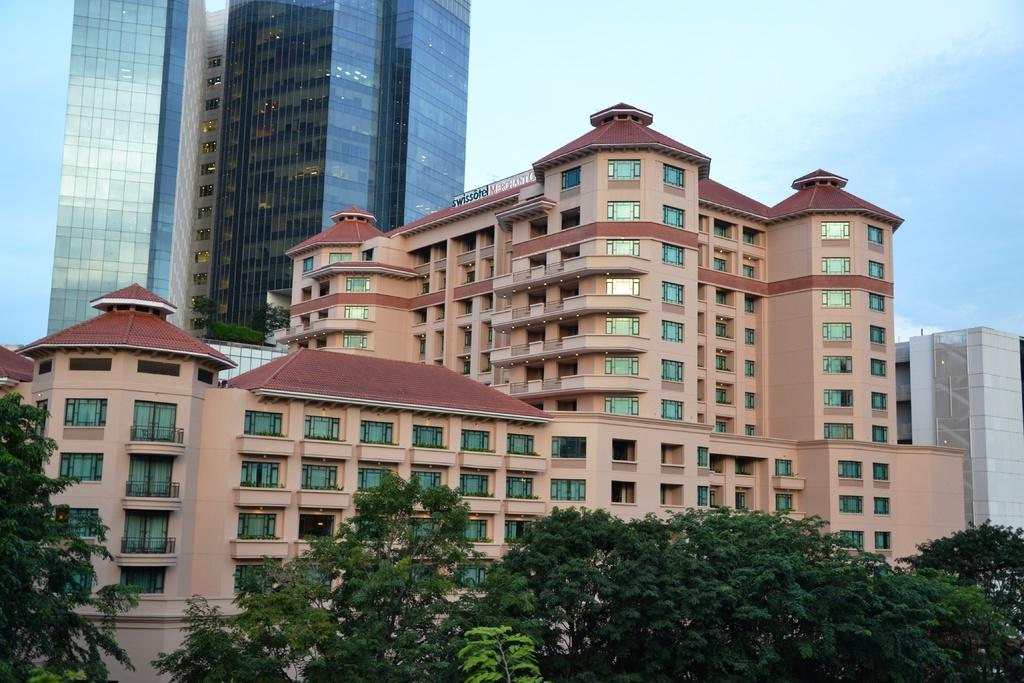What type of structures are visible in the image? There is a group of buildings with windows in the image. What can be seen on the signboard in the image? There is a signboard with text in the image. What type of vegetation is present in the image? There is a group of trees and plants in the image. What is the condition of the sky in the image? The sky is visible in the image and appears cloudy. Can you see any knees in the image? There are there any tigers or battles depicted in the image? 